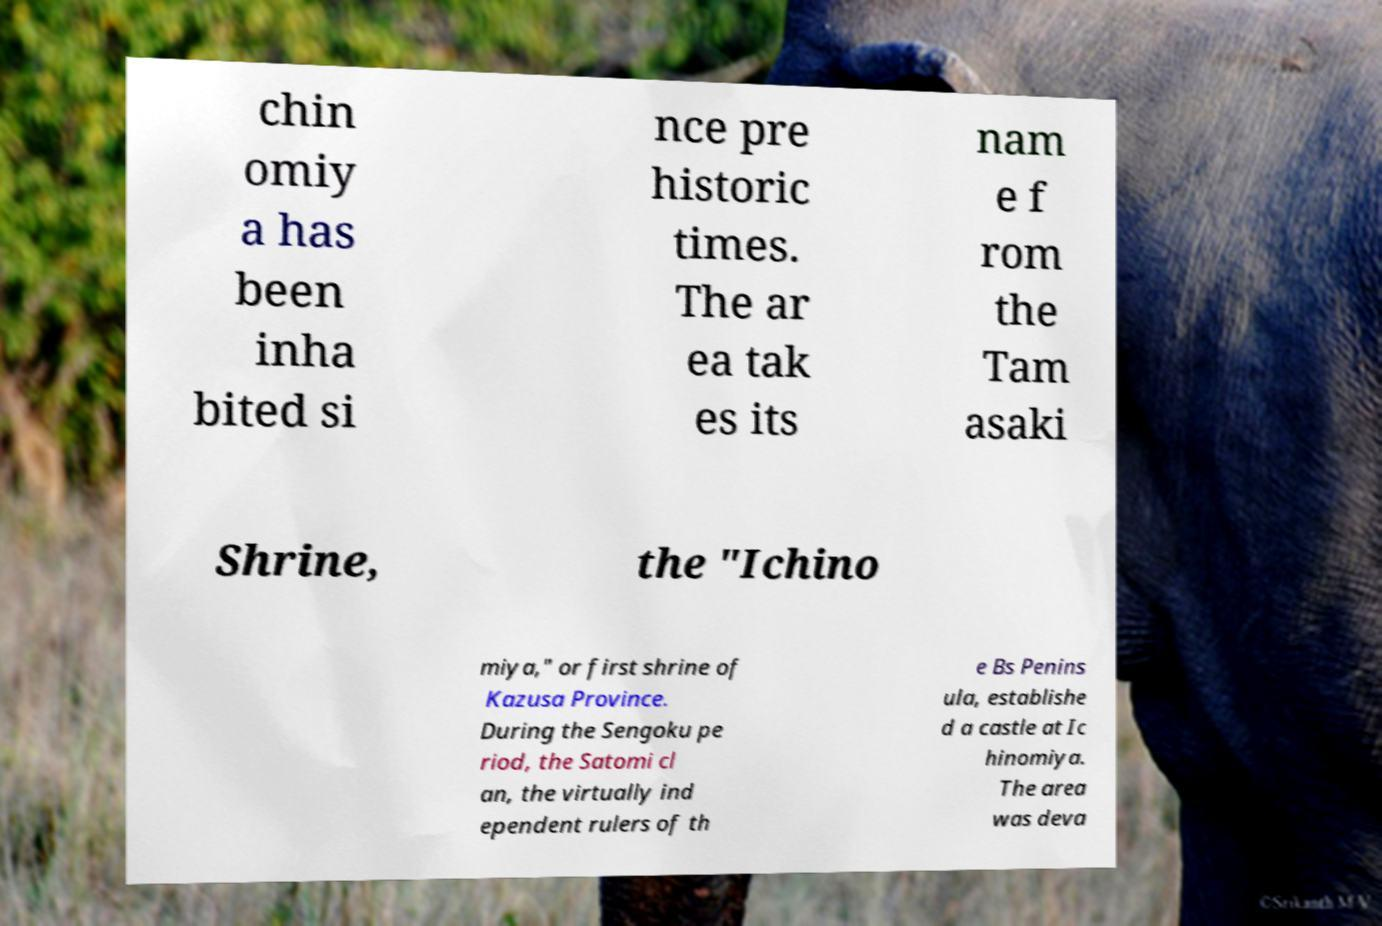Please identify and transcribe the text found in this image. chin omiy a has been inha bited si nce pre historic times. The ar ea tak es its nam e f rom the Tam asaki Shrine, the "Ichino miya," or first shrine of Kazusa Province. During the Sengoku pe riod, the Satomi cl an, the virtually ind ependent rulers of th e Bs Penins ula, establishe d a castle at Ic hinomiya. The area was deva 